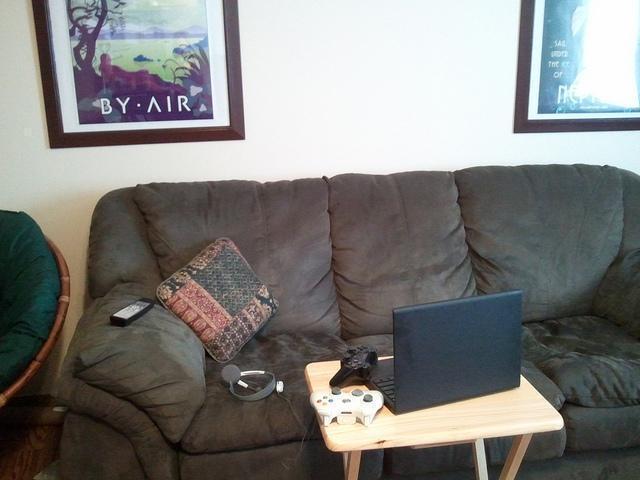Which gaming system is the white remote for on the table?
Select the accurate answer and provide justification: `Answer: choice
Rationale: srationale.`
Options: Gamecube, playstation, xbox, nintendo wii. Answer: xbox.
Rationale: The controllers on the wooden folding table are used to play playstation. 